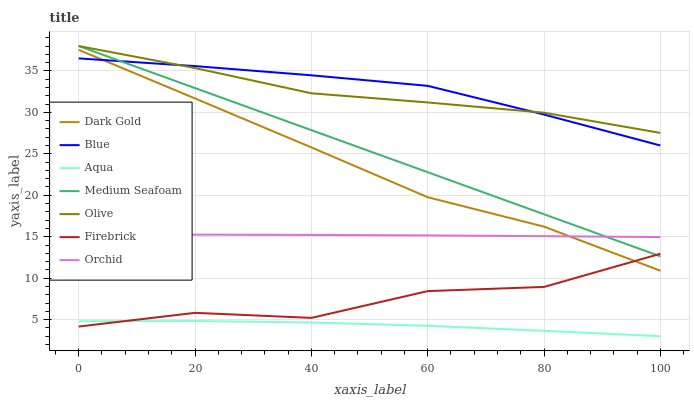Does Aqua have the minimum area under the curve?
Answer yes or no. Yes. Does Blue have the maximum area under the curve?
Answer yes or no. Yes. Does Dark Gold have the minimum area under the curve?
Answer yes or no. No. Does Dark Gold have the maximum area under the curve?
Answer yes or no. No. Is Medium Seafoam the smoothest?
Answer yes or no. Yes. Is Firebrick the roughest?
Answer yes or no. Yes. Is Dark Gold the smoothest?
Answer yes or no. No. Is Dark Gold the roughest?
Answer yes or no. No. Does Aqua have the lowest value?
Answer yes or no. Yes. Does Dark Gold have the lowest value?
Answer yes or no. No. Does Medium Seafoam have the highest value?
Answer yes or no. Yes. Does Dark Gold have the highest value?
Answer yes or no. No. Is Aqua less than Orchid?
Answer yes or no. Yes. Is Olive greater than Aqua?
Answer yes or no. Yes. Does Blue intersect Medium Seafoam?
Answer yes or no. Yes. Is Blue less than Medium Seafoam?
Answer yes or no. No. Is Blue greater than Medium Seafoam?
Answer yes or no. No. Does Aqua intersect Orchid?
Answer yes or no. No. 